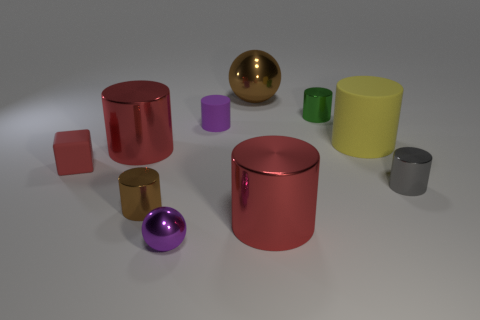What number of spheres are large purple matte objects or yellow rubber objects?
Offer a terse response. 0. Do the tiny green cylinder and the purple sphere have the same material?
Make the answer very short. Yes. What number of other things are there of the same color as the large metal sphere?
Ensure brevity in your answer.  1. There is a big red metal object to the left of the small purple rubber thing; what is its shape?
Your answer should be very brief. Cylinder. What number of objects are large red metal things or purple metallic balls?
Offer a very short reply. 3. There is a red rubber block; does it have the same size as the brown metal thing to the left of the tiny purple rubber object?
Provide a short and direct response. Yes. How many other things are made of the same material as the yellow thing?
Ensure brevity in your answer.  2. How many things are either shiny balls that are to the left of the purple cylinder or small cylinders behind the tiny brown cylinder?
Offer a terse response. 4. There is a tiny purple thing that is the same shape as the gray metallic thing; what material is it?
Your answer should be very brief. Rubber. Are there any gray matte objects?
Keep it short and to the point. No. 